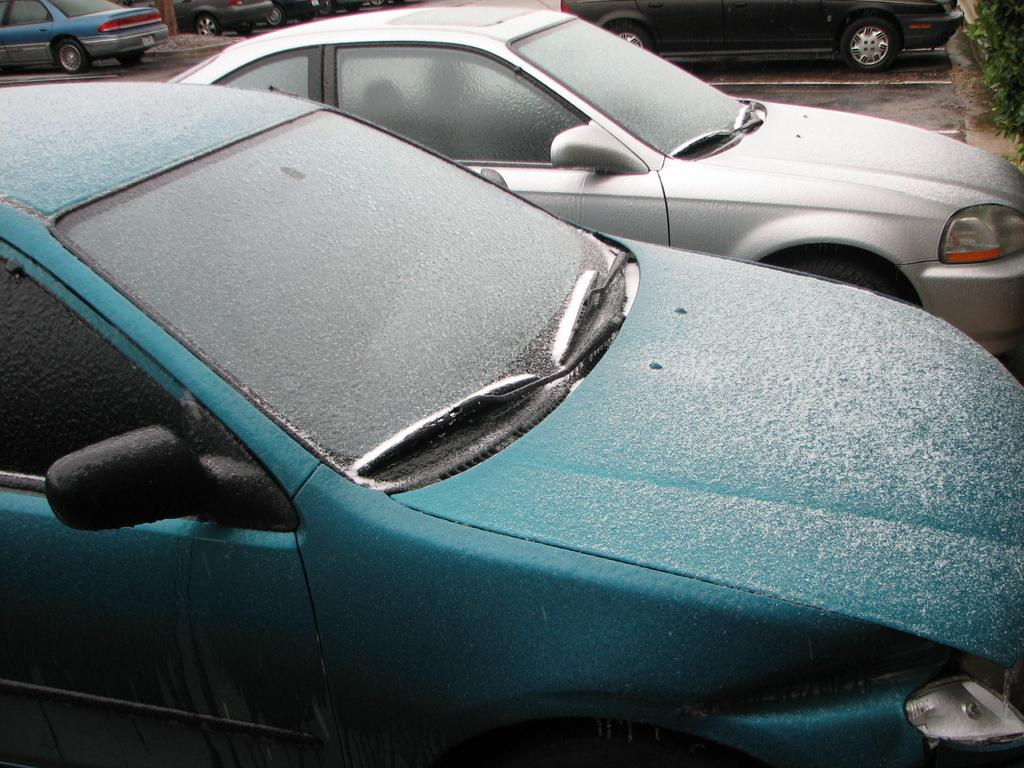What type of vehicles can be seen in the image? There are cars in the image. How are the cars distributed in the image? The cars are scattered throughout the image. What can be seen in the background on the right side of the image? There are plants in the background on the right side of the image. What type of suit can be seen hanging on the car in the image? There is no suit visible in the image; only cars and plants are present. 